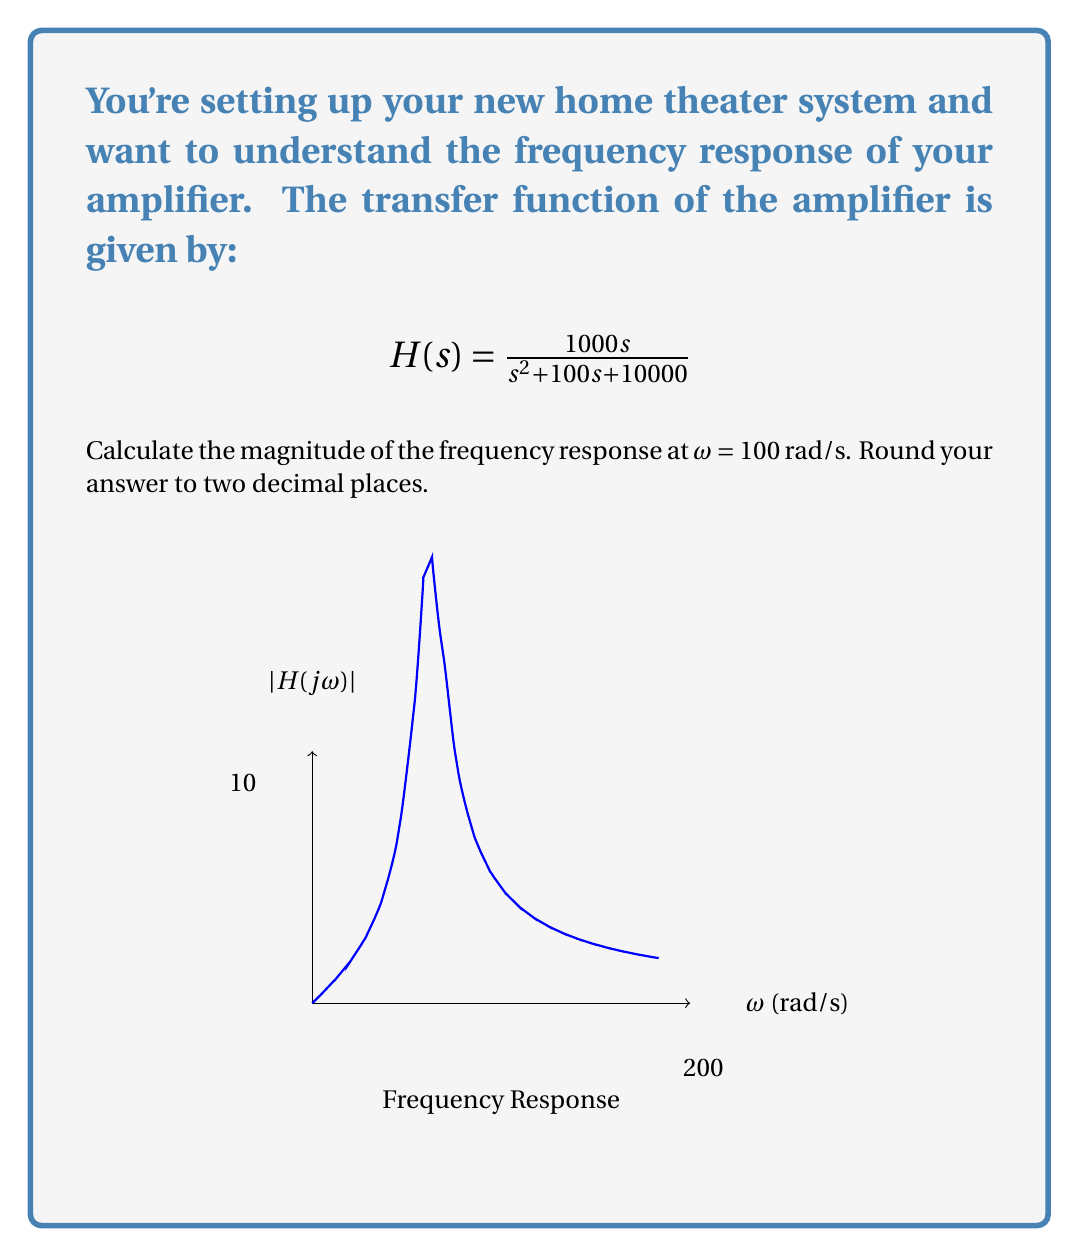Can you answer this question? To calculate the magnitude of the frequency response, we follow these steps:

1) The frequency response is obtained by evaluating $H(s)$ at $s = jω$:

   $$H(jω) = \frac{1000jω}{(jω)^2 + 100(jω) + 10000}$$

2) For ω = 100 rad/s, substitute this value:

   $$H(j100) = \frac{1000j100}{(j100)^2 + 100(j100) + 10000}$$

3) Simplify:
   
   $$H(j100) = \frac{100000j}{-10000 + 10000j + 10000} = \frac{100000j}{10000j}$$

4) The magnitude is given by $|H(jω)|$. For a complex number $a+bj$, the magnitude is $\sqrt{a^2 + b^2}$:

   $$|H(j100)| = \left|\frac{100000j}{10000j}\right| = \left|\frac{100000}{10000}\right| = 10$$

5) The question asks for the result rounded to two decimal places, so the final answer is 10.00.
Answer: 10.00 